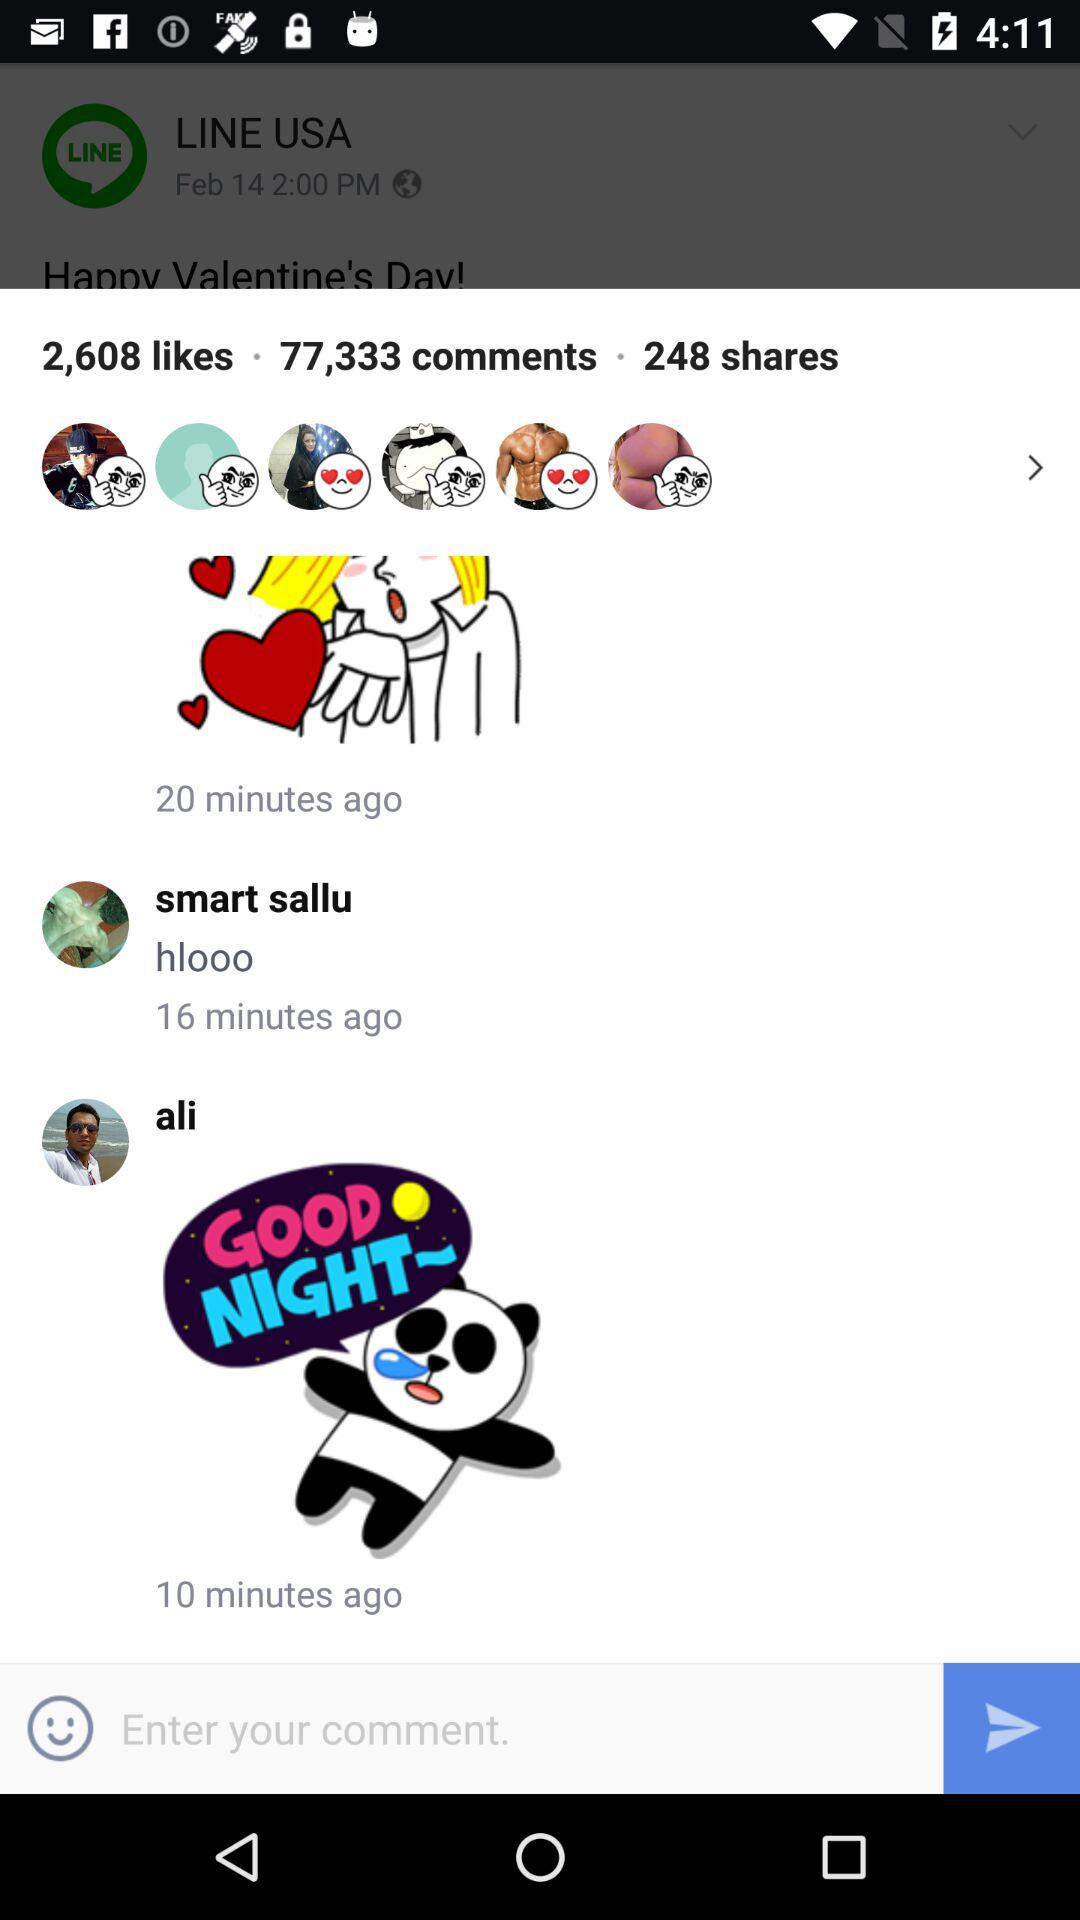How many comments are there? There are 77,333 comments. 